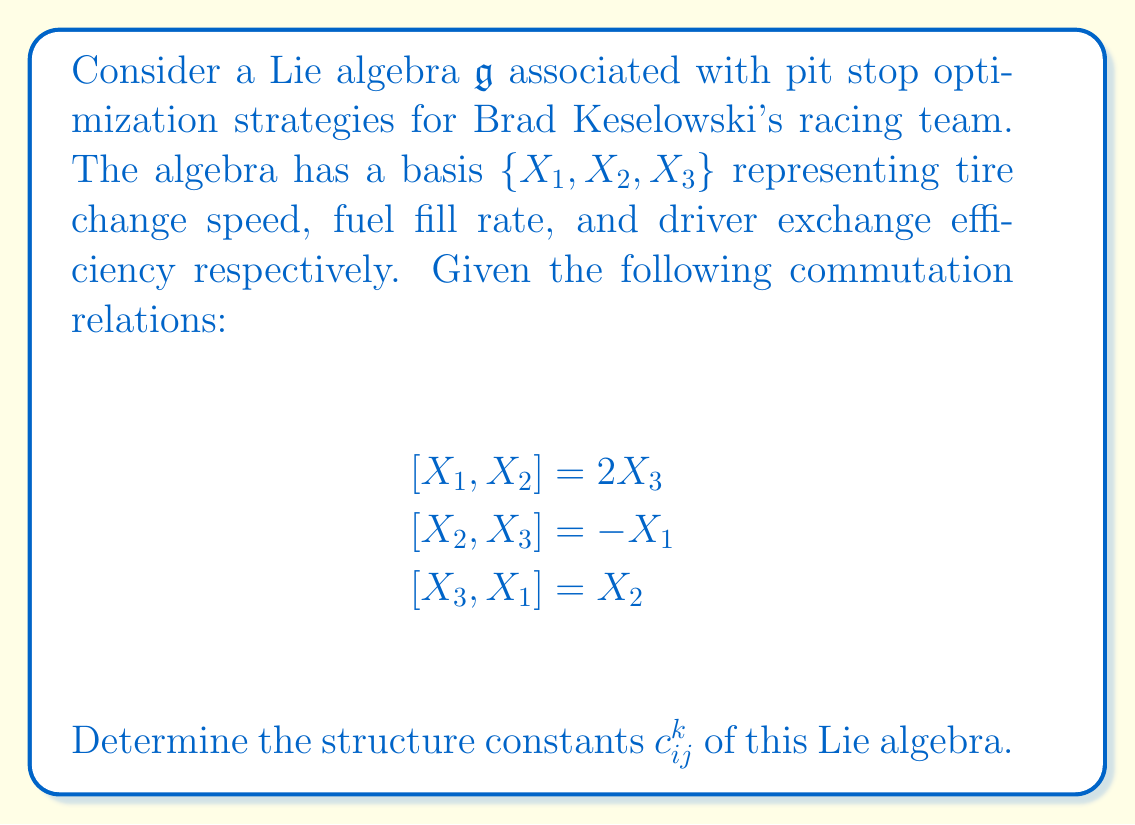Give your solution to this math problem. To solve this problem, we need to understand the concept of structure constants in Lie algebras and how they relate to the given commutation relations.

1) In a Lie algebra, the structure constants $c_{ij}^k$ are defined by the equation:

   $$[X_i, X_j] = \sum_{k=1}^n c_{ij}^k X_k$$

   where $n$ is the dimension of the Lie algebra (in this case, $n=3$).

2) We can read off the structure constants directly from the given commutation relations by comparing them with the general form above.

3) For $[X_1, X_2] = 2X_3$:
   - $c_{12}^3 = 2$
   - $c_{12}^1 = c_{12}^2 = 0$

4) For $[X_2, X_3] = -X_1$:
   - $c_{23}^1 = -1$
   - $c_{23}^2 = c_{23}^3 = 0$

5) For $[X_3, X_1] = X_2$:
   - $c_{31}^2 = 1$
   - $c_{31}^1 = c_{31}^3 = 0$

6) Note that the structure constants are antisymmetric in the lower indices:
   $c_{ij}^k = -c_{ji}^k$

   This gives us:
   - $c_{21}^3 = -2$
   - $c_{32}^1 = 1$
   - $c_{13}^2 = -1$

7) All other structure constants not mentioned are zero.
Answer: The non-zero structure constants of the Lie algebra are:

$$c_{12}^3 = 2, \quad c_{21}^3 = -2$$
$$c_{23}^1 = -1, \quad c_{32}^1 = 1$$
$$c_{31}^2 = 1, \quad c_{13}^2 = -1$$

All other $c_{ij}^k = 0$. 